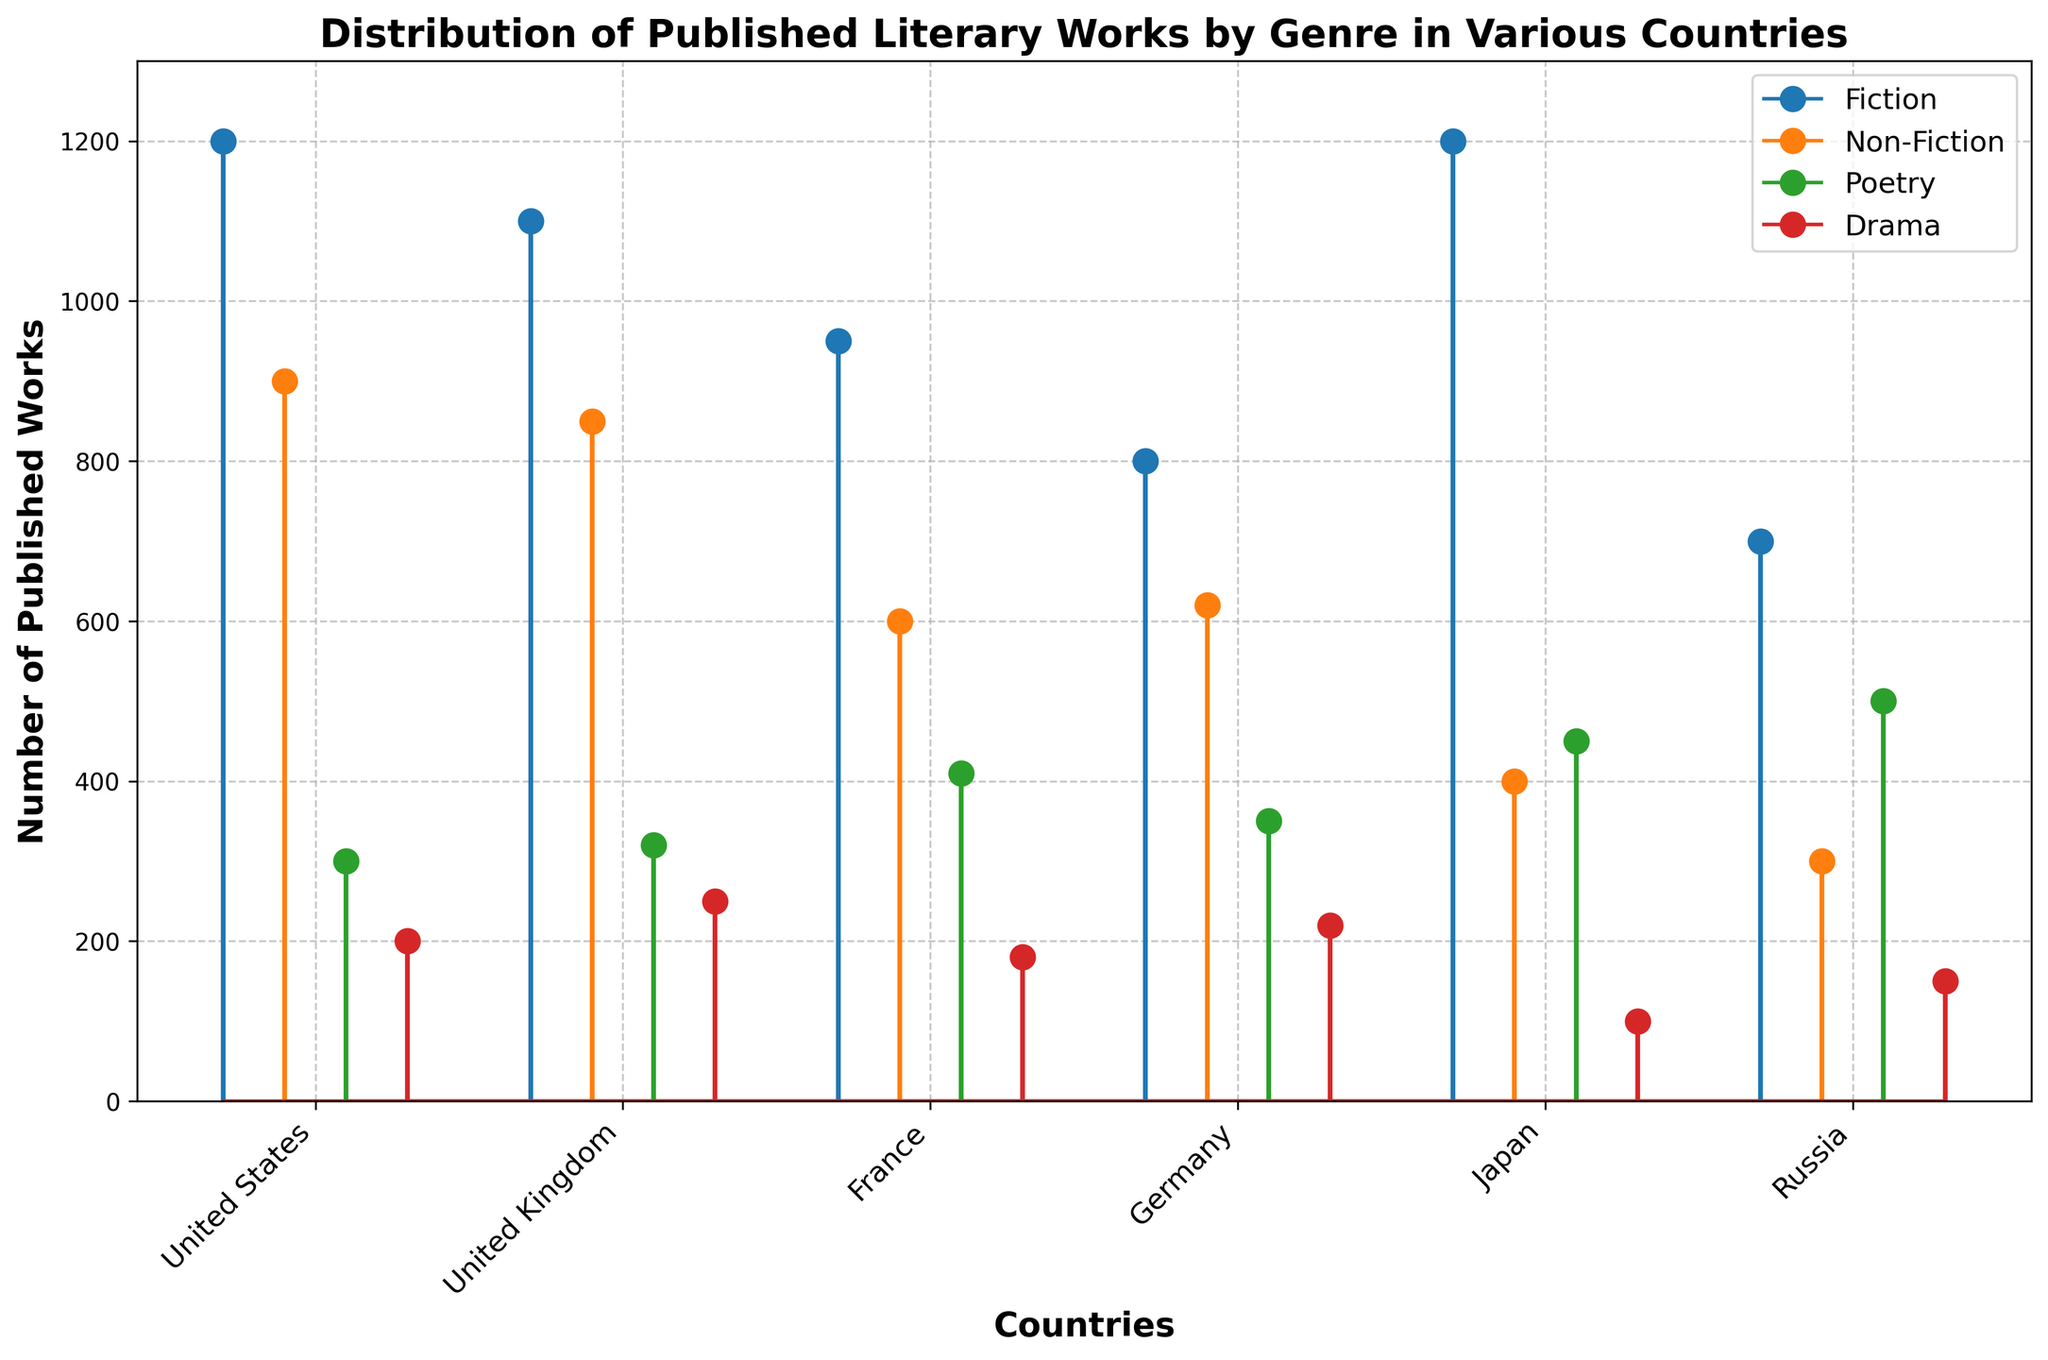what is the range of published fiction works between the countries? The range is calculated by identifying the country with the highest number of published fiction works and the country with the lowest. According to the stem plot, Japan and the United States each have the highest count with 1200, and Russia has the lowest count with 700. So, the range is 1200 - 700.
Answer: 500 Which country has the highest number of published poetry works? The highest number of published poetry works can be identified by the tallest marker in the "Poetry" series on the plot. According to the stem plot, Russia has the highest number with 500 published works.
Answer: Russia What is the combined total of published non-fiction works in France and Germany? To find the combined total, locate the non-fiction counts for France and Germany on the plot. France has 600, and Germany has 620 published non-fiction works. Adding these numbers gives 600 + 620 = 1220.
Answer: 1220 Which genre has the lowest publication in Japan? The lowest publication in Japan can be seen by identifying the shortest marker line for Japan. In the stem plot, Drama has the lowest publication with only 100 works.
Answer: Drama How does the number of published fiction works in Japan compare to those in the United Kingdom? To compare, locate the markers for fiction in Japan and the United Kingdom. Japan has 1200 published fiction works, while the United Kingdom has 1100. Thus, Japan has more published fiction works than the United Kingdom.
Answer: Japan What is the total number of published drama works across all countries? To find this total, sum the published drama works from each country: United States (200), United Kingdom (250), France (180), Germany (220), Japan (100), and Russia (150). The total is 200 + 250 + 180 + 220 + 100 + 150 = 1100.
Answer: 1100 Which country has the widest discrepancy in published works between its most and least popular genres? To determine the widest discrepancy, we need to identify the maximum and minimum counts for each country and calculate the differences. For each:
- United States: 1200 (Fiction) - 200 (Drama) = 1000
- United Kingdom: 1100 (Fiction) - 250 (Drama) = 850
- France: 950 (Fiction) - 180 (Drama) = 770
- Germany: 800 (Fiction) - 220 (Drama) = 580
- Japan: 1200 (Fiction) - 100 (Drama) = 1100
- Russia: 700 (Fiction) - 150 (Drama) = 550
The widest discrepancy is in Japan, with a difference of 1100.
Answer: Japan What is the average number of published works in the United States across all genres? To find the average, sum the published works across all genres in the United States: 1200 (Fiction) + 900 (Non-Fiction) + 300 (Poetry) + 200 (Drama) = 2600. Divide by the number of genres, which is 4. The average is 2600 / 4 = 650.
Answer: 650 Which genre has the smallest variance in number of published works across all countries? Variance measures the spread of data points. To find this, calculate the variance for each genre:
- Fiction: Variance([(1200, 1100, 950, 800, 1200, 700)]) = 39166.67
- Non-Fiction: Variance([(900, 850, 600, 620, 400, 300)]) = 46600.00
- Poetry: Variance([(300, 320, 410, 350, 450, 500)]) = 6166.67
- Drama: Variance([(200, 250, 180, 220, 100, 150)]) = 2775.00
Drama has the smallest variance with 2775.00.
Answer: Drama Which country shows the most balanced distribution in published works across all genres? Balance across genres can be estimated by checking the similarity in counts out of the lines for markers relative to each country.
- United States: Variance([(1200, 900, 300, 200)]) = 221250.00
- United Kingdom: Variance([(1100, 850, 320, 250)]) = 150150.00
- France: Variance([(950, 600, 410, 180)]) = 88516.67
- Germany: Variance([(800, 620, 350, 220)]) = 49416.67
- Japan: Variance([(1200, 400, 450, 100)]) = 165833.33
- Russia: Variance([(700, 300, 500, 150)]) = 41666.67
The most balanced distribution, indicated by the smallest variance, is in Russia with 41666.67.
Answer: Russia 